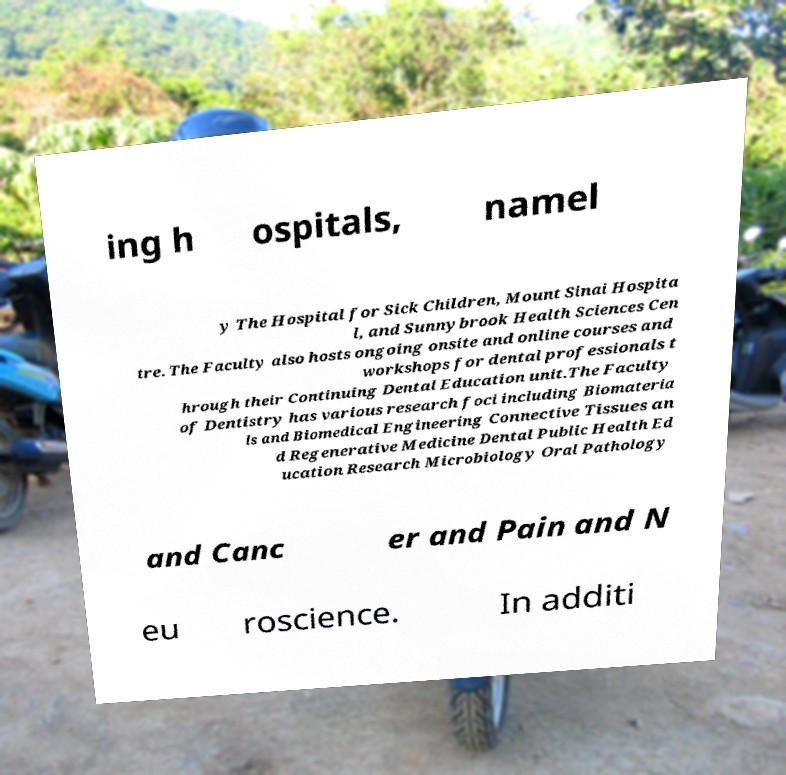Please read and relay the text visible in this image. What does it say? ing h ospitals, namel y The Hospital for Sick Children, Mount Sinai Hospita l, and Sunnybrook Health Sciences Cen tre. The Faculty also hosts ongoing onsite and online courses and workshops for dental professionals t hrough their Continuing Dental Education unit.The Faculty of Dentistry has various research foci including Biomateria ls and Biomedical Engineering Connective Tissues an d Regenerative Medicine Dental Public Health Ed ucation Research Microbiology Oral Pathology and Canc er and Pain and N eu roscience. In additi 